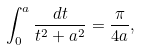<formula> <loc_0><loc_0><loc_500><loc_500>\int _ { 0 } ^ { a } \frac { d t } { t ^ { 2 } + a ^ { 2 } } = \frac { \pi } { 4 a } ,</formula> 